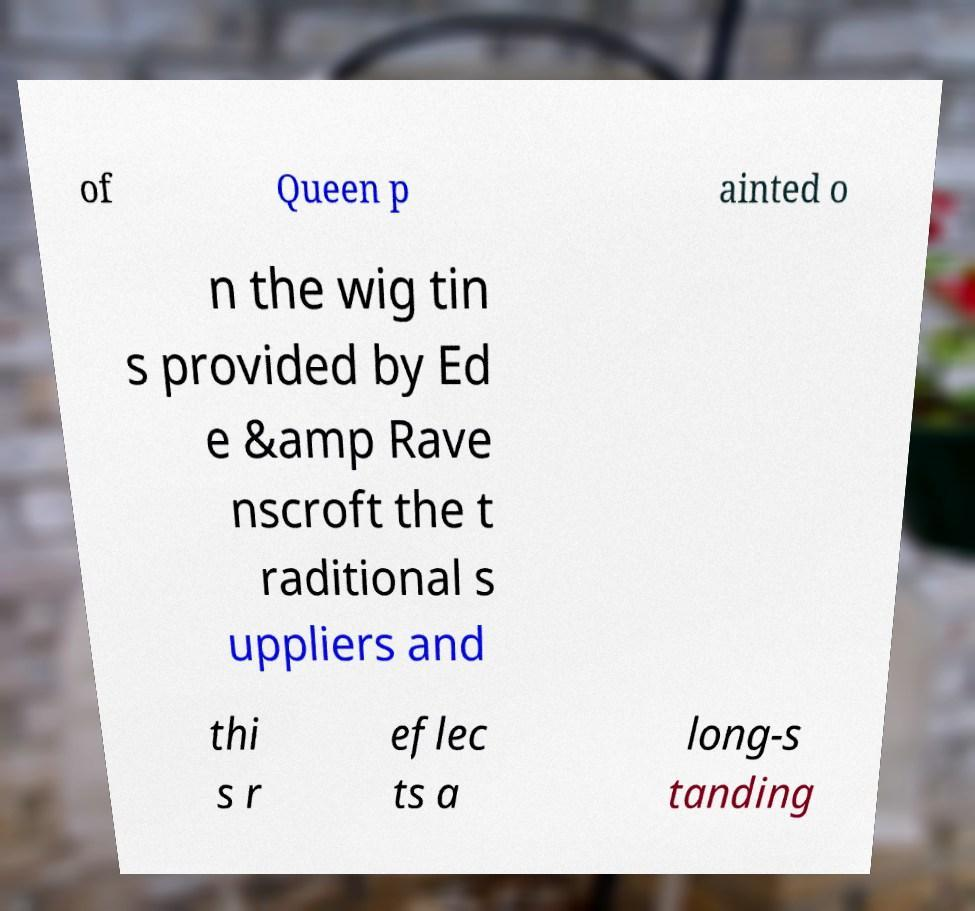Could you extract and type out the text from this image? of Queen p ainted o n the wig tin s provided by Ed e &amp Rave nscroft the t raditional s uppliers and thi s r eflec ts a long-s tanding 